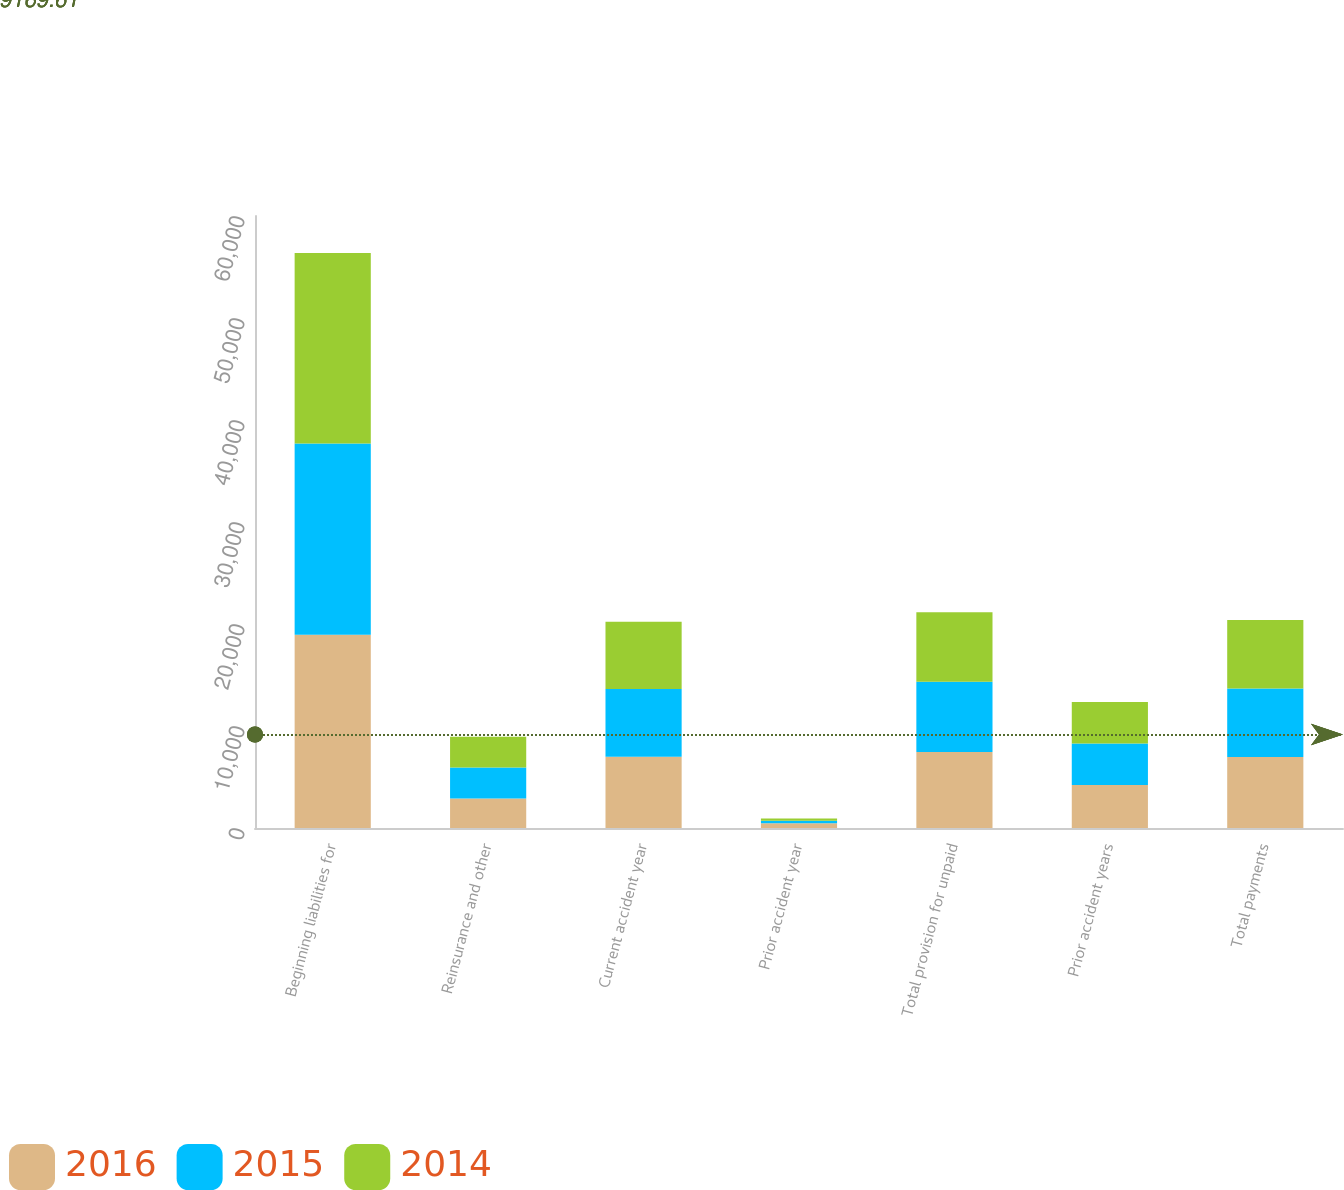Convert chart to OTSL. <chart><loc_0><loc_0><loc_500><loc_500><stacked_bar_chart><ecel><fcel>Beginning liabilities for<fcel>Reinsurance and other<fcel>Current accident year<fcel>Prior accident year<fcel>Total provision for unpaid<fcel>Prior accident years<fcel>Total payments<nl><fcel>2016<fcel>18943<fcel>2882<fcel>6990<fcel>457<fcel>7447<fcel>4219<fcel>6968<nl><fcel>2015<fcel>18765<fcel>3041<fcel>6647<fcel>250<fcel>6897<fcel>4066<fcel>6719<nl><fcel>2014<fcel>18676<fcel>3028<fcel>6572<fcel>228<fcel>6800<fcel>4072<fcel>6711<nl></chart> 